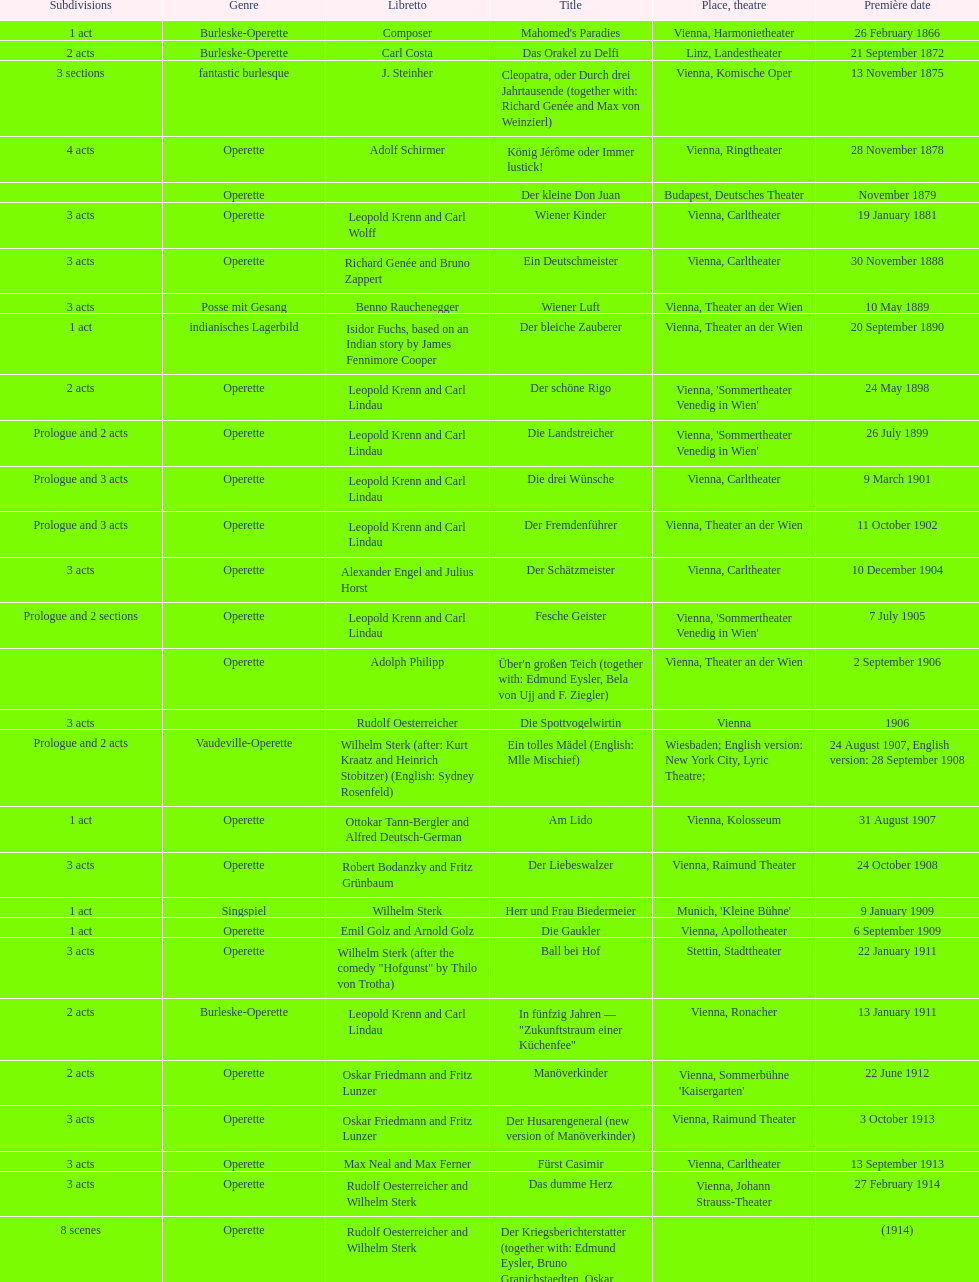In which urban center were the most operettas initially staged? Vienna. 